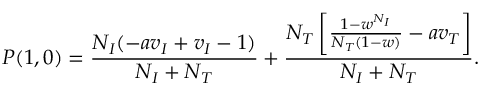Convert formula to latex. <formula><loc_0><loc_0><loc_500><loc_500>P ( 1 , 0 ) = \frac { N _ { I } ( - a v _ { I } + v _ { I } - 1 ) } { N _ { I } + N _ { T } } + \frac { N _ { T } \left [ \frac { 1 - w ^ { N _ { I } } } { N _ { T } ( 1 - w ) } - a v _ { T } \right ] } { N _ { I } + N _ { T } } .</formula> 